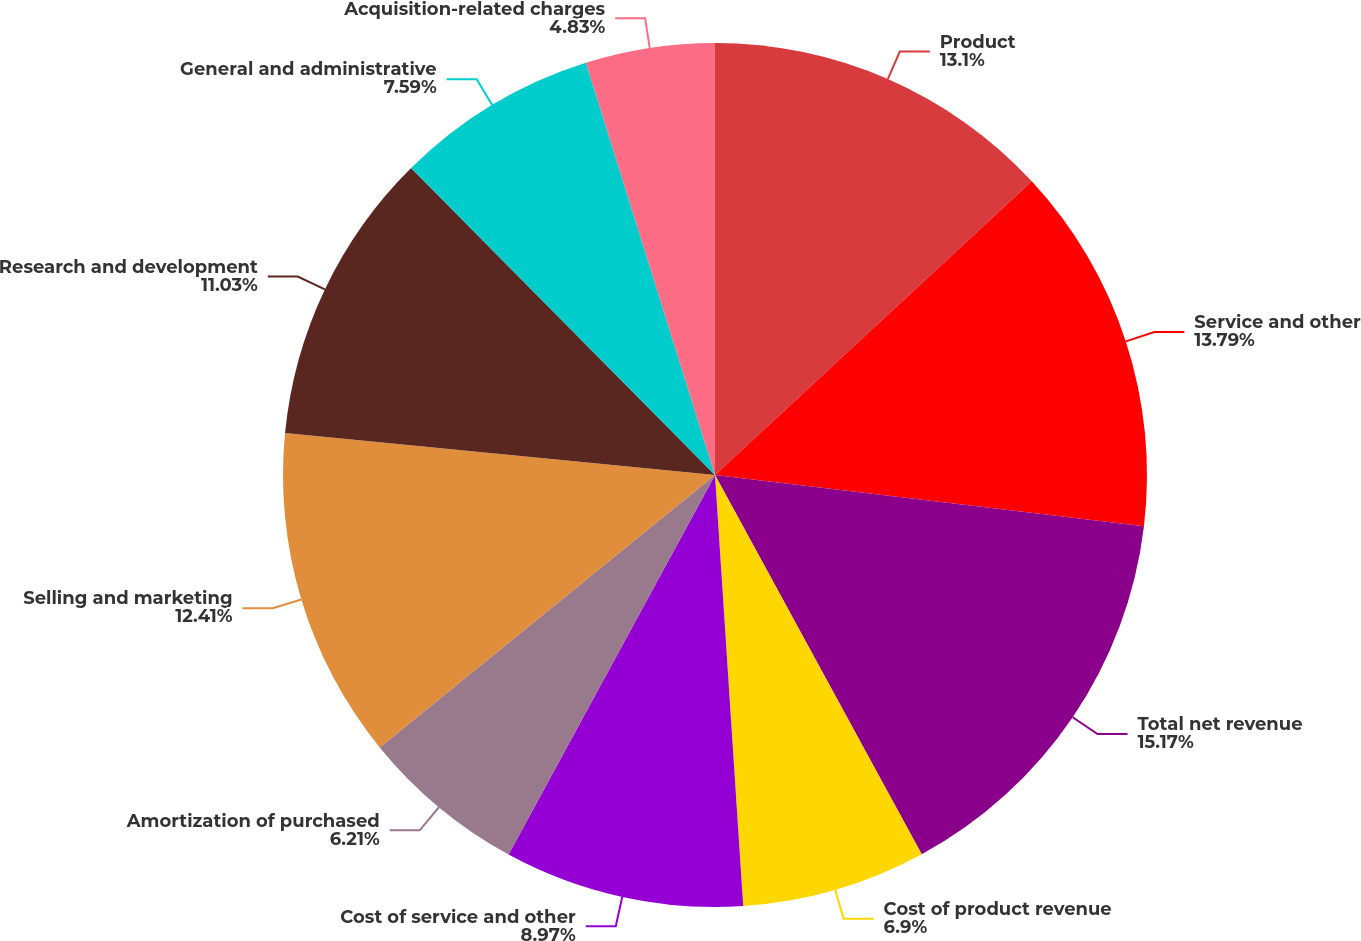Convert chart to OTSL. <chart><loc_0><loc_0><loc_500><loc_500><pie_chart><fcel>Product<fcel>Service and other<fcel>Total net revenue<fcel>Cost of product revenue<fcel>Cost of service and other<fcel>Amortization of purchased<fcel>Selling and marketing<fcel>Research and development<fcel>General and administrative<fcel>Acquisition-related charges<nl><fcel>13.1%<fcel>13.79%<fcel>15.17%<fcel>6.9%<fcel>8.97%<fcel>6.21%<fcel>12.41%<fcel>11.03%<fcel>7.59%<fcel>4.83%<nl></chart> 